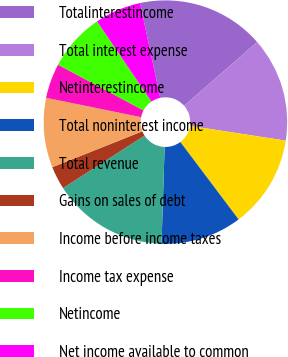<chart> <loc_0><loc_0><loc_500><loc_500><pie_chart><fcel>Totalinterestincome<fcel>Total interest expense<fcel>Netinterestincome<fcel>Total noninterest income<fcel>Total revenue<fcel>Gains on sales of debt<fcel>Income before income taxes<fcel>Income tax expense<fcel>Netincome<fcel>Net income available to common<nl><fcel>16.92%<fcel>13.85%<fcel>12.31%<fcel>10.77%<fcel>15.38%<fcel>3.08%<fcel>9.23%<fcel>4.62%<fcel>7.69%<fcel>6.15%<nl></chart> 